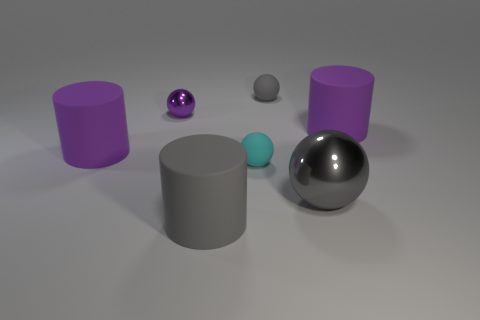Is the material of the large gray sphere the same as the purple sphere?
Give a very brief answer. Yes. There is a large rubber thing that is behind the big gray cylinder and right of the small purple metallic sphere; what is its shape?
Your response must be concise. Cylinder. There is a purple rubber object in front of the cylinder right of the gray metallic sphere; what size is it?
Your answer should be very brief. Large. What number of other tiny rubber objects have the same shape as the small cyan object?
Provide a succinct answer. 1. Are there any small metallic objects that have the same color as the large metal object?
Provide a short and direct response. No. Do the tiny purple thing in front of the gray matte sphere and the cylinder that is on the left side of the small purple metal sphere have the same material?
Your answer should be compact. No. The tiny metallic ball has what color?
Provide a short and direct response. Purple. There is a sphere left of the rubber thing that is in front of the shiny thing right of the small cyan rubber object; how big is it?
Your response must be concise. Small. What number of other objects are there of the same size as the purple shiny sphere?
Give a very brief answer. 2. What number of other balls have the same material as the small purple sphere?
Give a very brief answer. 1. 